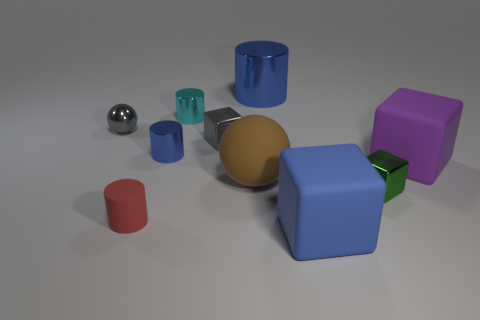Imagine if this were a scene from a story, what role could these objects play? In the tapestry of a story, these objects could represent a collection of mystical artifacts, each with its own unique power. The large blue cube might be the central source of energy, the metallic sphere a divining orb, and the other colored shapes could be keys to unlock different dimensions or possess various elemental powers. 